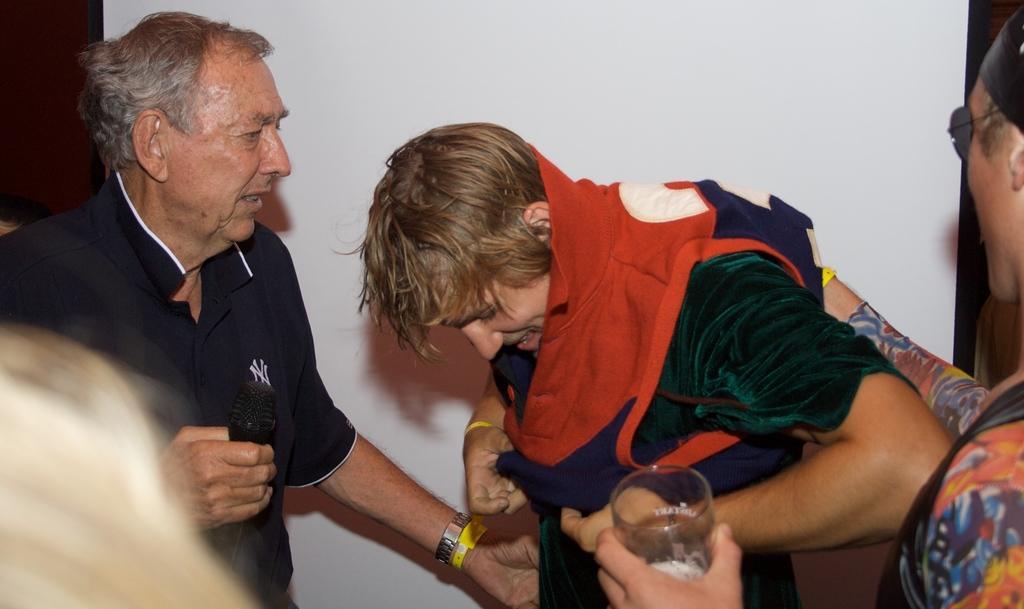Describe this image in one or two sentences. To the right corner of the image there is a man with goggles and holding a glass in his hand. In front of him there is a man wearing a t-shirt. Beside him there is a man with black t-shirt is standing and holding a mic in his hand. And behind them there is a white color wall. 